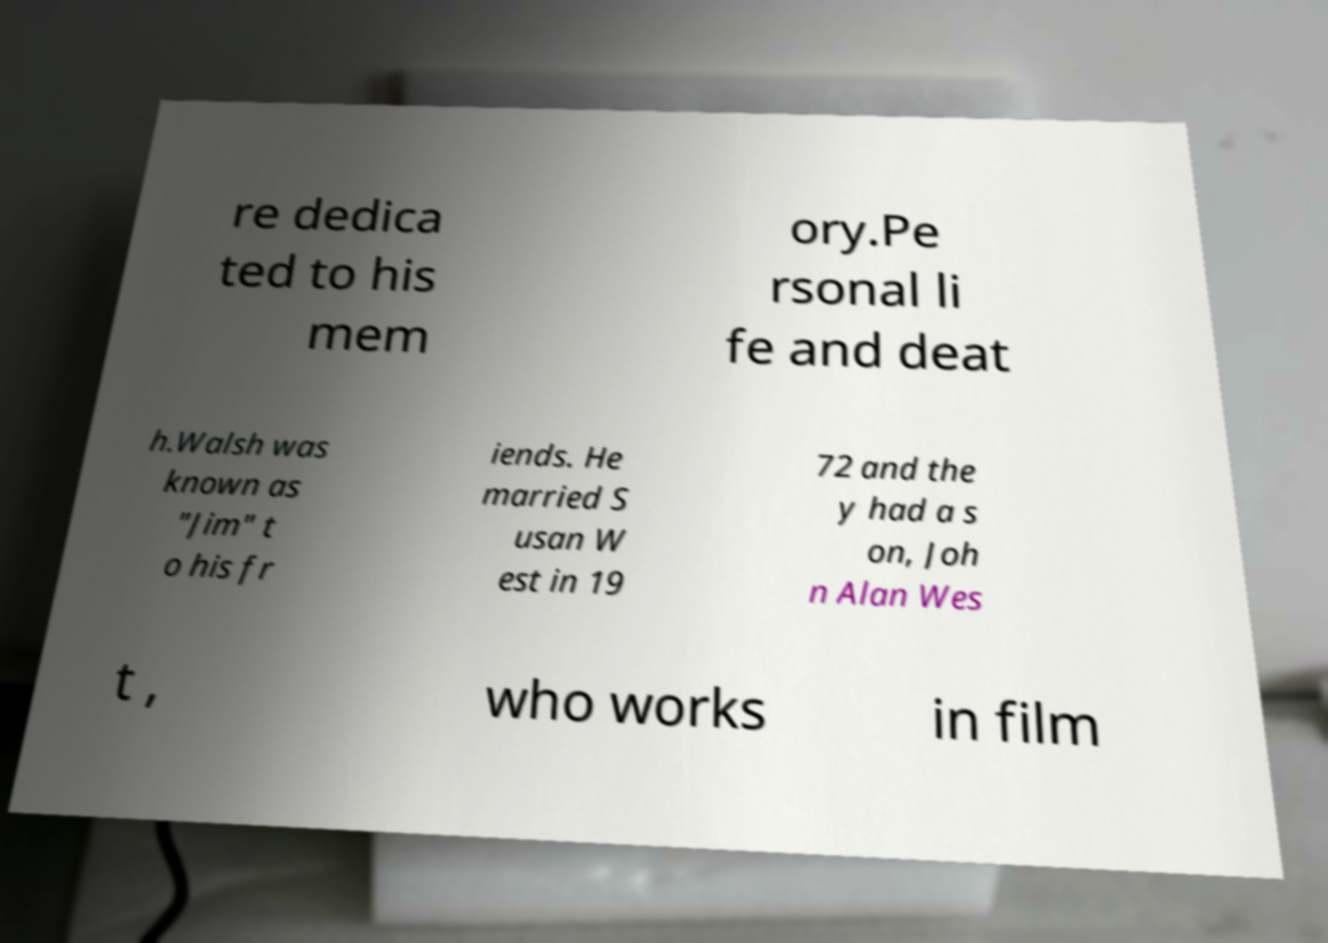I need the written content from this picture converted into text. Can you do that? re dedica ted to his mem ory.Pe rsonal li fe and deat h.Walsh was known as "Jim" t o his fr iends. He married S usan W est in 19 72 and the y had a s on, Joh n Alan Wes t , who works in film 